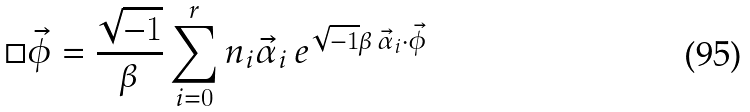<formula> <loc_0><loc_0><loc_500><loc_500>\Box \vec { \phi } = \frac { \sqrt { - 1 } } { \beta } \sum ^ { r } _ { i = 0 } n _ { i } \vec { \alpha } _ { i } \, e ^ { \sqrt { - 1 } \beta \, \vec { \alpha } _ { i } \cdot \vec { \phi } }</formula> 